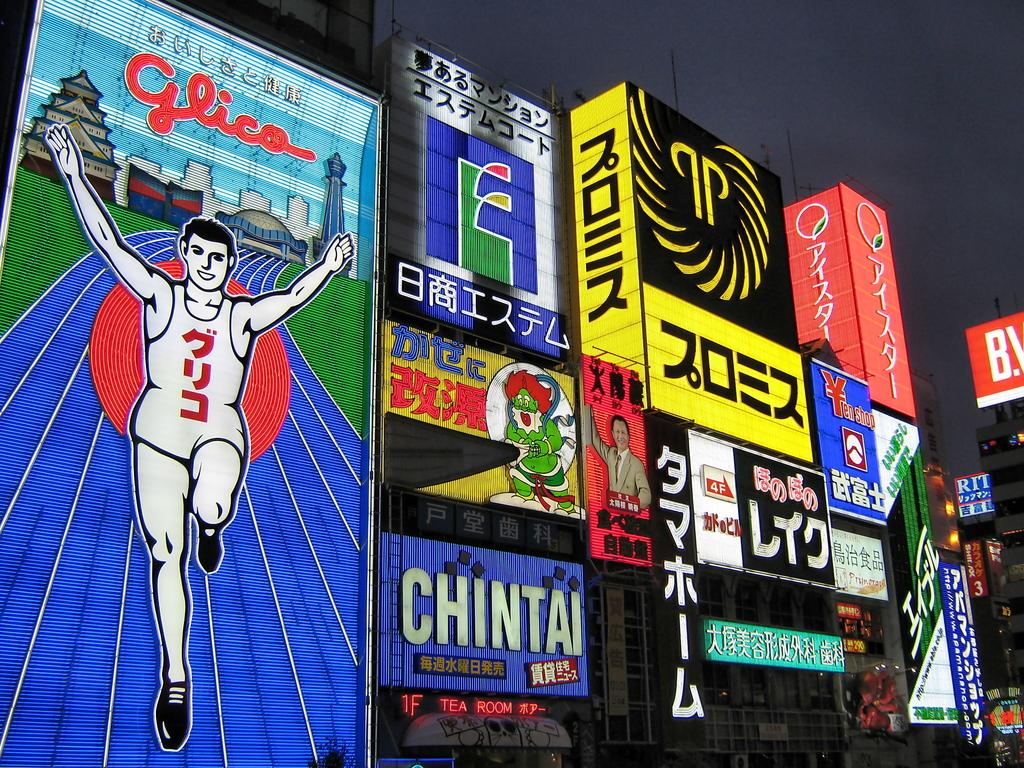Provide a one-sentence caption for the provided image. A bunch of billboard with the one in the middle having the word Chintai on it. 